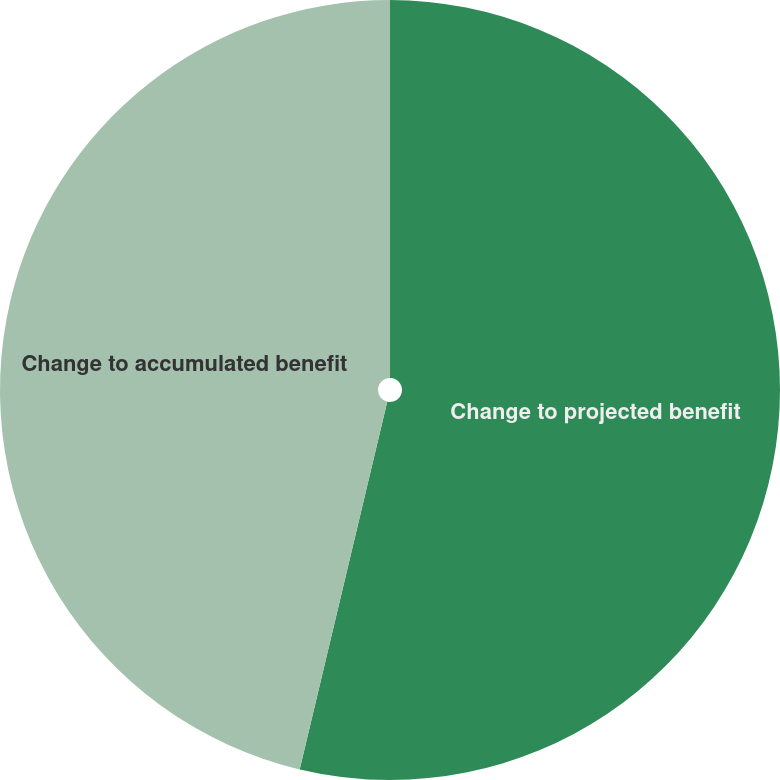Convert chart to OTSL. <chart><loc_0><loc_0><loc_500><loc_500><pie_chart><fcel>Change to projected benefit<fcel>Change to accumulated benefit<nl><fcel>53.72%<fcel>46.28%<nl></chart> 